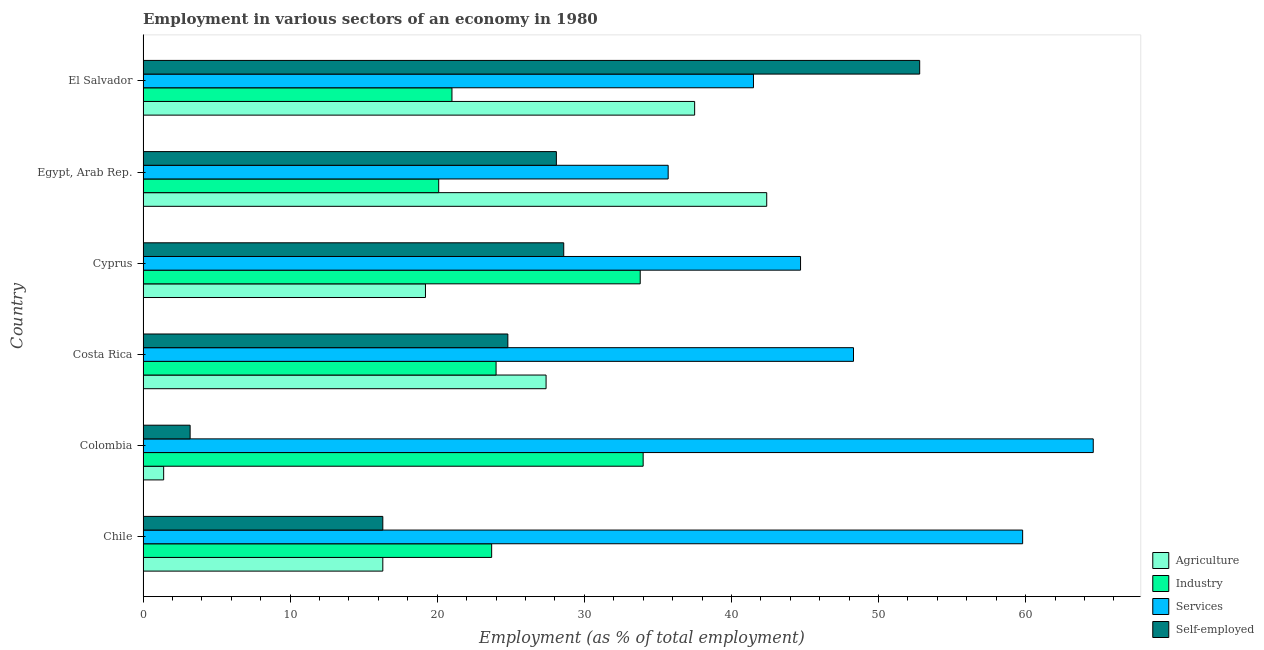How many different coloured bars are there?
Make the answer very short. 4. Are the number of bars per tick equal to the number of legend labels?
Ensure brevity in your answer.  Yes. Are the number of bars on each tick of the Y-axis equal?
Your answer should be compact. Yes. How many bars are there on the 6th tick from the top?
Make the answer very short. 4. What is the percentage of workers in services in Colombia?
Your answer should be very brief. 64.6. Across all countries, what is the maximum percentage of workers in services?
Keep it short and to the point. 64.6. Across all countries, what is the minimum percentage of workers in industry?
Give a very brief answer. 20.1. In which country was the percentage of workers in agriculture maximum?
Provide a succinct answer. Egypt, Arab Rep. In which country was the percentage of workers in services minimum?
Give a very brief answer. Egypt, Arab Rep. What is the total percentage of workers in services in the graph?
Provide a succinct answer. 294.6. What is the difference between the percentage of workers in agriculture in Chile and that in Cyprus?
Your response must be concise. -2.9. What is the average percentage of self employed workers per country?
Offer a very short reply. 25.63. What is the difference between the percentage of workers in industry and percentage of workers in services in Colombia?
Your answer should be compact. -30.6. In how many countries, is the percentage of workers in agriculture greater than 12 %?
Offer a very short reply. 5. What is the ratio of the percentage of workers in agriculture in Chile to that in Colombia?
Offer a very short reply. 11.64. Is the percentage of workers in industry in Chile less than that in Colombia?
Provide a short and direct response. Yes. What is the difference between the highest and the second highest percentage of self employed workers?
Your response must be concise. 24.2. Is the sum of the percentage of workers in services in Costa Rica and Cyprus greater than the maximum percentage of workers in industry across all countries?
Provide a succinct answer. Yes. What does the 1st bar from the top in Cyprus represents?
Provide a short and direct response. Self-employed. What does the 1st bar from the bottom in Colombia represents?
Keep it short and to the point. Agriculture. Is it the case that in every country, the sum of the percentage of workers in agriculture and percentage of workers in industry is greater than the percentage of workers in services?
Your answer should be compact. No. How many bars are there?
Your response must be concise. 24. How many countries are there in the graph?
Offer a very short reply. 6. Does the graph contain grids?
Your answer should be compact. No. Where does the legend appear in the graph?
Your response must be concise. Bottom right. How are the legend labels stacked?
Your answer should be compact. Vertical. What is the title of the graph?
Give a very brief answer. Employment in various sectors of an economy in 1980. Does "Insurance services" appear as one of the legend labels in the graph?
Provide a short and direct response. No. What is the label or title of the X-axis?
Your answer should be very brief. Employment (as % of total employment). What is the label or title of the Y-axis?
Offer a terse response. Country. What is the Employment (as % of total employment) of Agriculture in Chile?
Your answer should be compact. 16.3. What is the Employment (as % of total employment) in Industry in Chile?
Your answer should be very brief. 23.7. What is the Employment (as % of total employment) in Services in Chile?
Your answer should be very brief. 59.8. What is the Employment (as % of total employment) in Self-employed in Chile?
Provide a short and direct response. 16.3. What is the Employment (as % of total employment) in Agriculture in Colombia?
Keep it short and to the point. 1.4. What is the Employment (as % of total employment) of Services in Colombia?
Keep it short and to the point. 64.6. What is the Employment (as % of total employment) of Self-employed in Colombia?
Offer a very short reply. 3.2. What is the Employment (as % of total employment) in Agriculture in Costa Rica?
Offer a very short reply. 27.4. What is the Employment (as % of total employment) in Industry in Costa Rica?
Provide a succinct answer. 24. What is the Employment (as % of total employment) of Services in Costa Rica?
Ensure brevity in your answer.  48.3. What is the Employment (as % of total employment) of Self-employed in Costa Rica?
Ensure brevity in your answer.  24.8. What is the Employment (as % of total employment) in Agriculture in Cyprus?
Ensure brevity in your answer.  19.2. What is the Employment (as % of total employment) in Industry in Cyprus?
Your answer should be very brief. 33.8. What is the Employment (as % of total employment) in Services in Cyprus?
Give a very brief answer. 44.7. What is the Employment (as % of total employment) of Self-employed in Cyprus?
Your answer should be very brief. 28.6. What is the Employment (as % of total employment) of Agriculture in Egypt, Arab Rep.?
Keep it short and to the point. 42.4. What is the Employment (as % of total employment) in Industry in Egypt, Arab Rep.?
Your answer should be very brief. 20.1. What is the Employment (as % of total employment) in Services in Egypt, Arab Rep.?
Your response must be concise. 35.7. What is the Employment (as % of total employment) of Self-employed in Egypt, Arab Rep.?
Your response must be concise. 28.1. What is the Employment (as % of total employment) in Agriculture in El Salvador?
Ensure brevity in your answer.  37.5. What is the Employment (as % of total employment) in Services in El Salvador?
Keep it short and to the point. 41.5. What is the Employment (as % of total employment) of Self-employed in El Salvador?
Ensure brevity in your answer.  52.8. Across all countries, what is the maximum Employment (as % of total employment) of Agriculture?
Ensure brevity in your answer.  42.4. Across all countries, what is the maximum Employment (as % of total employment) of Services?
Your response must be concise. 64.6. Across all countries, what is the maximum Employment (as % of total employment) of Self-employed?
Offer a very short reply. 52.8. Across all countries, what is the minimum Employment (as % of total employment) of Agriculture?
Make the answer very short. 1.4. Across all countries, what is the minimum Employment (as % of total employment) of Industry?
Provide a short and direct response. 20.1. Across all countries, what is the minimum Employment (as % of total employment) of Services?
Offer a very short reply. 35.7. Across all countries, what is the minimum Employment (as % of total employment) of Self-employed?
Provide a succinct answer. 3.2. What is the total Employment (as % of total employment) of Agriculture in the graph?
Your response must be concise. 144.2. What is the total Employment (as % of total employment) of Industry in the graph?
Provide a succinct answer. 156.6. What is the total Employment (as % of total employment) of Services in the graph?
Give a very brief answer. 294.6. What is the total Employment (as % of total employment) of Self-employed in the graph?
Provide a succinct answer. 153.8. What is the difference between the Employment (as % of total employment) in Agriculture in Chile and that in Colombia?
Your answer should be very brief. 14.9. What is the difference between the Employment (as % of total employment) in Industry in Chile and that in Colombia?
Offer a terse response. -10.3. What is the difference between the Employment (as % of total employment) in Self-employed in Chile and that in Colombia?
Provide a short and direct response. 13.1. What is the difference between the Employment (as % of total employment) in Agriculture in Chile and that in Costa Rica?
Make the answer very short. -11.1. What is the difference between the Employment (as % of total employment) of Services in Chile and that in Costa Rica?
Your answer should be very brief. 11.5. What is the difference between the Employment (as % of total employment) in Agriculture in Chile and that in Cyprus?
Ensure brevity in your answer.  -2.9. What is the difference between the Employment (as % of total employment) in Industry in Chile and that in Cyprus?
Keep it short and to the point. -10.1. What is the difference between the Employment (as % of total employment) of Self-employed in Chile and that in Cyprus?
Keep it short and to the point. -12.3. What is the difference between the Employment (as % of total employment) in Agriculture in Chile and that in Egypt, Arab Rep.?
Offer a very short reply. -26.1. What is the difference between the Employment (as % of total employment) in Services in Chile and that in Egypt, Arab Rep.?
Your answer should be very brief. 24.1. What is the difference between the Employment (as % of total employment) in Self-employed in Chile and that in Egypt, Arab Rep.?
Give a very brief answer. -11.8. What is the difference between the Employment (as % of total employment) in Agriculture in Chile and that in El Salvador?
Your response must be concise. -21.2. What is the difference between the Employment (as % of total employment) of Industry in Chile and that in El Salvador?
Make the answer very short. 2.7. What is the difference between the Employment (as % of total employment) in Self-employed in Chile and that in El Salvador?
Ensure brevity in your answer.  -36.5. What is the difference between the Employment (as % of total employment) in Industry in Colombia and that in Costa Rica?
Make the answer very short. 10. What is the difference between the Employment (as % of total employment) of Self-employed in Colombia and that in Costa Rica?
Offer a very short reply. -21.6. What is the difference between the Employment (as % of total employment) in Agriculture in Colombia and that in Cyprus?
Your answer should be compact. -17.8. What is the difference between the Employment (as % of total employment) in Self-employed in Colombia and that in Cyprus?
Offer a terse response. -25.4. What is the difference between the Employment (as % of total employment) of Agriculture in Colombia and that in Egypt, Arab Rep.?
Make the answer very short. -41. What is the difference between the Employment (as % of total employment) of Services in Colombia and that in Egypt, Arab Rep.?
Ensure brevity in your answer.  28.9. What is the difference between the Employment (as % of total employment) in Self-employed in Colombia and that in Egypt, Arab Rep.?
Keep it short and to the point. -24.9. What is the difference between the Employment (as % of total employment) of Agriculture in Colombia and that in El Salvador?
Your answer should be compact. -36.1. What is the difference between the Employment (as % of total employment) in Services in Colombia and that in El Salvador?
Your answer should be very brief. 23.1. What is the difference between the Employment (as % of total employment) in Self-employed in Colombia and that in El Salvador?
Your answer should be very brief. -49.6. What is the difference between the Employment (as % of total employment) of Agriculture in Costa Rica and that in Cyprus?
Your answer should be very brief. 8.2. What is the difference between the Employment (as % of total employment) in Services in Costa Rica and that in Cyprus?
Offer a terse response. 3.6. What is the difference between the Employment (as % of total employment) in Self-employed in Costa Rica and that in Cyprus?
Your answer should be compact. -3.8. What is the difference between the Employment (as % of total employment) of Agriculture in Costa Rica and that in Egypt, Arab Rep.?
Make the answer very short. -15. What is the difference between the Employment (as % of total employment) in Industry in Costa Rica and that in Egypt, Arab Rep.?
Provide a succinct answer. 3.9. What is the difference between the Employment (as % of total employment) in Industry in Costa Rica and that in El Salvador?
Provide a succinct answer. 3. What is the difference between the Employment (as % of total employment) of Self-employed in Costa Rica and that in El Salvador?
Make the answer very short. -28. What is the difference between the Employment (as % of total employment) in Agriculture in Cyprus and that in Egypt, Arab Rep.?
Offer a very short reply. -23.2. What is the difference between the Employment (as % of total employment) in Services in Cyprus and that in Egypt, Arab Rep.?
Offer a terse response. 9. What is the difference between the Employment (as % of total employment) in Self-employed in Cyprus and that in Egypt, Arab Rep.?
Provide a short and direct response. 0.5. What is the difference between the Employment (as % of total employment) in Agriculture in Cyprus and that in El Salvador?
Keep it short and to the point. -18.3. What is the difference between the Employment (as % of total employment) of Industry in Cyprus and that in El Salvador?
Your response must be concise. 12.8. What is the difference between the Employment (as % of total employment) of Services in Cyprus and that in El Salvador?
Ensure brevity in your answer.  3.2. What is the difference between the Employment (as % of total employment) in Self-employed in Cyprus and that in El Salvador?
Offer a terse response. -24.2. What is the difference between the Employment (as % of total employment) in Agriculture in Egypt, Arab Rep. and that in El Salvador?
Your response must be concise. 4.9. What is the difference between the Employment (as % of total employment) of Services in Egypt, Arab Rep. and that in El Salvador?
Your answer should be compact. -5.8. What is the difference between the Employment (as % of total employment) of Self-employed in Egypt, Arab Rep. and that in El Salvador?
Your answer should be very brief. -24.7. What is the difference between the Employment (as % of total employment) in Agriculture in Chile and the Employment (as % of total employment) in Industry in Colombia?
Your answer should be compact. -17.7. What is the difference between the Employment (as % of total employment) of Agriculture in Chile and the Employment (as % of total employment) of Services in Colombia?
Ensure brevity in your answer.  -48.3. What is the difference between the Employment (as % of total employment) in Agriculture in Chile and the Employment (as % of total employment) in Self-employed in Colombia?
Keep it short and to the point. 13.1. What is the difference between the Employment (as % of total employment) of Industry in Chile and the Employment (as % of total employment) of Services in Colombia?
Your response must be concise. -40.9. What is the difference between the Employment (as % of total employment) in Services in Chile and the Employment (as % of total employment) in Self-employed in Colombia?
Your response must be concise. 56.6. What is the difference between the Employment (as % of total employment) of Agriculture in Chile and the Employment (as % of total employment) of Industry in Costa Rica?
Provide a short and direct response. -7.7. What is the difference between the Employment (as % of total employment) of Agriculture in Chile and the Employment (as % of total employment) of Services in Costa Rica?
Provide a succinct answer. -32. What is the difference between the Employment (as % of total employment) in Agriculture in Chile and the Employment (as % of total employment) in Self-employed in Costa Rica?
Offer a terse response. -8.5. What is the difference between the Employment (as % of total employment) of Industry in Chile and the Employment (as % of total employment) of Services in Costa Rica?
Provide a succinct answer. -24.6. What is the difference between the Employment (as % of total employment) in Industry in Chile and the Employment (as % of total employment) in Self-employed in Costa Rica?
Your response must be concise. -1.1. What is the difference between the Employment (as % of total employment) in Agriculture in Chile and the Employment (as % of total employment) in Industry in Cyprus?
Your answer should be compact. -17.5. What is the difference between the Employment (as % of total employment) of Agriculture in Chile and the Employment (as % of total employment) of Services in Cyprus?
Provide a succinct answer. -28.4. What is the difference between the Employment (as % of total employment) of Industry in Chile and the Employment (as % of total employment) of Self-employed in Cyprus?
Give a very brief answer. -4.9. What is the difference between the Employment (as % of total employment) of Services in Chile and the Employment (as % of total employment) of Self-employed in Cyprus?
Offer a very short reply. 31.2. What is the difference between the Employment (as % of total employment) of Agriculture in Chile and the Employment (as % of total employment) of Industry in Egypt, Arab Rep.?
Give a very brief answer. -3.8. What is the difference between the Employment (as % of total employment) of Agriculture in Chile and the Employment (as % of total employment) of Services in Egypt, Arab Rep.?
Your response must be concise. -19.4. What is the difference between the Employment (as % of total employment) of Services in Chile and the Employment (as % of total employment) of Self-employed in Egypt, Arab Rep.?
Provide a short and direct response. 31.7. What is the difference between the Employment (as % of total employment) in Agriculture in Chile and the Employment (as % of total employment) in Industry in El Salvador?
Provide a short and direct response. -4.7. What is the difference between the Employment (as % of total employment) of Agriculture in Chile and the Employment (as % of total employment) of Services in El Salvador?
Keep it short and to the point. -25.2. What is the difference between the Employment (as % of total employment) in Agriculture in Chile and the Employment (as % of total employment) in Self-employed in El Salvador?
Your answer should be very brief. -36.5. What is the difference between the Employment (as % of total employment) in Industry in Chile and the Employment (as % of total employment) in Services in El Salvador?
Provide a succinct answer. -17.8. What is the difference between the Employment (as % of total employment) in Industry in Chile and the Employment (as % of total employment) in Self-employed in El Salvador?
Give a very brief answer. -29.1. What is the difference between the Employment (as % of total employment) of Services in Chile and the Employment (as % of total employment) of Self-employed in El Salvador?
Offer a very short reply. 7. What is the difference between the Employment (as % of total employment) in Agriculture in Colombia and the Employment (as % of total employment) in Industry in Costa Rica?
Ensure brevity in your answer.  -22.6. What is the difference between the Employment (as % of total employment) in Agriculture in Colombia and the Employment (as % of total employment) in Services in Costa Rica?
Ensure brevity in your answer.  -46.9. What is the difference between the Employment (as % of total employment) of Agriculture in Colombia and the Employment (as % of total employment) of Self-employed in Costa Rica?
Keep it short and to the point. -23.4. What is the difference between the Employment (as % of total employment) in Industry in Colombia and the Employment (as % of total employment) in Services in Costa Rica?
Ensure brevity in your answer.  -14.3. What is the difference between the Employment (as % of total employment) of Services in Colombia and the Employment (as % of total employment) of Self-employed in Costa Rica?
Your answer should be very brief. 39.8. What is the difference between the Employment (as % of total employment) in Agriculture in Colombia and the Employment (as % of total employment) in Industry in Cyprus?
Provide a short and direct response. -32.4. What is the difference between the Employment (as % of total employment) of Agriculture in Colombia and the Employment (as % of total employment) of Services in Cyprus?
Keep it short and to the point. -43.3. What is the difference between the Employment (as % of total employment) of Agriculture in Colombia and the Employment (as % of total employment) of Self-employed in Cyprus?
Provide a short and direct response. -27.2. What is the difference between the Employment (as % of total employment) in Industry in Colombia and the Employment (as % of total employment) in Self-employed in Cyprus?
Provide a short and direct response. 5.4. What is the difference between the Employment (as % of total employment) of Agriculture in Colombia and the Employment (as % of total employment) of Industry in Egypt, Arab Rep.?
Keep it short and to the point. -18.7. What is the difference between the Employment (as % of total employment) in Agriculture in Colombia and the Employment (as % of total employment) in Services in Egypt, Arab Rep.?
Offer a very short reply. -34.3. What is the difference between the Employment (as % of total employment) in Agriculture in Colombia and the Employment (as % of total employment) in Self-employed in Egypt, Arab Rep.?
Your answer should be very brief. -26.7. What is the difference between the Employment (as % of total employment) of Industry in Colombia and the Employment (as % of total employment) of Services in Egypt, Arab Rep.?
Ensure brevity in your answer.  -1.7. What is the difference between the Employment (as % of total employment) of Industry in Colombia and the Employment (as % of total employment) of Self-employed in Egypt, Arab Rep.?
Offer a very short reply. 5.9. What is the difference between the Employment (as % of total employment) in Services in Colombia and the Employment (as % of total employment) in Self-employed in Egypt, Arab Rep.?
Provide a succinct answer. 36.5. What is the difference between the Employment (as % of total employment) in Agriculture in Colombia and the Employment (as % of total employment) in Industry in El Salvador?
Provide a short and direct response. -19.6. What is the difference between the Employment (as % of total employment) in Agriculture in Colombia and the Employment (as % of total employment) in Services in El Salvador?
Your answer should be very brief. -40.1. What is the difference between the Employment (as % of total employment) of Agriculture in Colombia and the Employment (as % of total employment) of Self-employed in El Salvador?
Give a very brief answer. -51.4. What is the difference between the Employment (as % of total employment) in Industry in Colombia and the Employment (as % of total employment) in Self-employed in El Salvador?
Make the answer very short. -18.8. What is the difference between the Employment (as % of total employment) of Services in Colombia and the Employment (as % of total employment) of Self-employed in El Salvador?
Your answer should be very brief. 11.8. What is the difference between the Employment (as % of total employment) in Agriculture in Costa Rica and the Employment (as % of total employment) in Industry in Cyprus?
Give a very brief answer. -6.4. What is the difference between the Employment (as % of total employment) of Agriculture in Costa Rica and the Employment (as % of total employment) of Services in Cyprus?
Ensure brevity in your answer.  -17.3. What is the difference between the Employment (as % of total employment) in Agriculture in Costa Rica and the Employment (as % of total employment) in Self-employed in Cyprus?
Provide a succinct answer. -1.2. What is the difference between the Employment (as % of total employment) in Industry in Costa Rica and the Employment (as % of total employment) in Services in Cyprus?
Keep it short and to the point. -20.7. What is the difference between the Employment (as % of total employment) in Industry in Costa Rica and the Employment (as % of total employment) in Self-employed in Cyprus?
Your answer should be compact. -4.6. What is the difference between the Employment (as % of total employment) of Agriculture in Costa Rica and the Employment (as % of total employment) of Industry in Egypt, Arab Rep.?
Keep it short and to the point. 7.3. What is the difference between the Employment (as % of total employment) in Industry in Costa Rica and the Employment (as % of total employment) in Self-employed in Egypt, Arab Rep.?
Provide a succinct answer. -4.1. What is the difference between the Employment (as % of total employment) of Services in Costa Rica and the Employment (as % of total employment) of Self-employed in Egypt, Arab Rep.?
Provide a succinct answer. 20.2. What is the difference between the Employment (as % of total employment) in Agriculture in Costa Rica and the Employment (as % of total employment) in Industry in El Salvador?
Your response must be concise. 6.4. What is the difference between the Employment (as % of total employment) in Agriculture in Costa Rica and the Employment (as % of total employment) in Services in El Salvador?
Your response must be concise. -14.1. What is the difference between the Employment (as % of total employment) of Agriculture in Costa Rica and the Employment (as % of total employment) of Self-employed in El Salvador?
Provide a succinct answer. -25.4. What is the difference between the Employment (as % of total employment) of Industry in Costa Rica and the Employment (as % of total employment) of Services in El Salvador?
Your answer should be compact. -17.5. What is the difference between the Employment (as % of total employment) of Industry in Costa Rica and the Employment (as % of total employment) of Self-employed in El Salvador?
Ensure brevity in your answer.  -28.8. What is the difference between the Employment (as % of total employment) in Agriculture in Cyprus and the Employment (as % of total employment) in Industry in Egypt, Arab Rep.?
Ensure brevity in your answer.  -0.9. What is the difference between the Employment (as % of total employment) of Agriculture in Cyprus and the Employment (as % of total employment) of Services in Egypt, Arab Rep.?
Your answer should be compact. -16.5. What is the difference between the Employment (as % of total employment) in Agriculture in Cyprus and the Employment (as % of total employment) in Self-employed in Egypt, Arab Rep.?
Provide a succinct answer. -8.9. What is the difference between the Employment (as % of total employment) of Industry in Cyprus and the Employment (as % of total employment) of Self-employed in Egypt, Arab Rep.?
Ensure brevity in your answer.  5.7. What is the difference between the Employment (as % of total employment) in Services in Cyprus and the Employment (as % of total employment) in Self-employed in Egypt, Arab Rep.?
Provide a short and direct response. 16.6. What is the difference between the Employment (as % of total employment) of Agriculture in Cyprus and the Employment (as % of total employment) of Industry in El Salvador?
Offer a terse response. -1.8. What is the difference between the Employment (as % of total employment) of Agriculture in Cyprus and the Employment (as % of total employment) of Services in El Salvador?
Your answer should be very brief. -22.3. What is the difference between the Employment (as % of total employment) of Agriculture in Cyprus and the Employment (as % of total employment) of Self-employed in El Salvador?
Provide a short and direct response. -33.6. What is the difference between the Employment (as % of total employment) in Agriculture in Egypt, Arab Rep. and the Employment (as % of total employment) in Industry in El Salvador?
Offer a terse response. 21.4. What is the difference between the Employment (as % of total employment) in Industry in Egypt, Arab Rep. and the Employment (as % of total employment) in Services in El Salvador?
Offer a terse response. -21.4. What is the difference between the Employment (as % of total employment) of Industry in Egypt, Arab Rep. and the Employment (as % of total employment) of Self-employed in El Salvador?
Make the answer very short. -32.7. What is the difference between the Employment (as % of total employment) of Services in Egypt, Arab Rep. and the Employment (as % of total employment) of Self-employed in El Salvador?
Your answer should be very brief. -17.1. What is the average Employment (as % of total employment) of Agriculture per country?
Make the answer very short. 24.03. What is the average Employment (as % of total employment) of Industry per country?
Your response must be concise. 26.1. What is the average Employment (as % of total employment) in Services per country?
Offer a terse response. 49.1. What is the average Employment (as % of total employment) in Self-employed per country?
Your answer should be very brief. 25.63. What is the difference between the Employment (as % of total employment) of Agriculture and Employment (as % of total employment) of Services in Chile?
Your response must be concise. -43.5. What is the difference between the Employment (as % of total employment) of Industry and Employment (as % of total employment) of Services in Chile?
Keep it short and to the point. -36.1. What is the difference between the Employment (as % of total employment) of Industry and Employment (as % of total employment) of Self-employed in Chile?
Ensure brevity in your answer.  7.4. What is the difference between the Employment (as % of total employment) of Services and Employment (as % of total employment) of Self-employed in Chile?
Provide a short and direct response. 43.5. What is the difference between the Employment (as % of total employment) of Agriculture and Employment (as % of total employment) of Industry in Colombia?
Offer a very short reply. -32.6. What is the difference between the Employment (as % of total employment) in Agriculture and Employment (as % of total employment) in Services in Colombia?
Provide a succinct answer. -63.2. What is the difference between the Employment (as % of total employment) in Agriculture and Employment (as % of total employment) in Self-employed in Colombia?
Offer a terse response. -1.8. What is the difference between the Employment (as % of total employment) of Industry and Employment (as % of total employment) of Services in Colombia?
Your response must be concise. -30.6. What is the difference between the Employment (as % of total employment) in Industry and Employment (as % of total employment) in Self-employed in Colombia?
Provide a short and direct response. 30.8. What is the difference between the Employment (as % of total employment) in Services and Employment (as % of total employment) in Self-employed in Colombia?
Offer a terse response. 61.4. What is the difference between the Employment (as % of total employment) of Agriculture and Employment (as % of total employment) of Services in Costa Rica?
Offer a very short reply. -20.9. What is the difference between the Employment (as % of total employment) in Agriculture and Employment (as % of total employment) in Self-employed in Costa Rica?
Offer a terse response. 2.6. What is the difference between the Employment (as % of total employment) of Industry and Employment (as % of total employment) of Services in Costa Rica?
Provide a succinct answer. -24.3. What is the difference between the Employment (as % of total employment) in Services and Employment (as % of total employment) in Self-employed in Costa Rica?
Provide a succinct answer. 23.5. What is the difference between the Employment (as % of total employment) in Agriculture and Employment (as % of total employment) in Industry in Cyprus?
Offer a terse response. -14.6. What is the difference between the Employment (as % of total employment) in Agriculture and Employment (as % of total employment) in Services in Cyprus?
Your answer should be very brief. -25.5. What is the difference between the Employment (as % of total employment) of Agriculture and Employment (as % of total employment) of Self-employed in Cyprus?
Your answer should be very brief. -9.4. What is the difference between the Employment (as % of total employment) of Industry and Employment (as % of total employment) of Self-employed in Cyprus?
Ensure brevity in your answer.  5.2. What is the difference between the Employment (as % of total employment) in Services and Employment (as % of total employment) in Self-employed in Cyprus?
Give a very brief answer. 16.1. What is the difference between the Employment (as % of total employment) of Agriculture and Employment (as % of total employment) of Industry in Egypt, Arab Rep.?
Your answer should be very brief. 22.3. What is the difference between the Employment (as % of total employment) in Industry and Employment (as % of total employment) in Services in Egypt, Arab Rep.?
Provide a succinct answer. -15.6. What is the difference between the Employment (as % of total employment) of Agriculture and Employment (as % of total employment) of Self-employed in El Salvador?
Keep it short and to the point. -15.3. What is the difference between the Employment (as % of total employment) of Industry and Employment (as % of total employment) of Services in El Salvador?
Give a very brief answer. -20.5. What is the difference between the Employment (as % of total employment) of Industry and Employment (as % of total employment) of Self-employed in El Salvador?
Your response must be concise. -31.8. What is the difference between the Employment (as % of total employment) of Services and Employment (as % of total employment) of Self-employed in El Salvador?
Your answer should be very brief. -11.3. What is the ratio of the Employment (as % of total employment) in Agriculture in Chile to that in Colombia?
Ensure brevity in your answer.  11.64. What is the ratio of the Employment (as % of total employment) of Industry in Chile to that in Colombia?
Provide a succinct answer. 0.7. What is the ratio of the Employment (as % of total employment) in Services in Chile to that in Colombia?
Make the answer very short. 0.93. What is the ratio of the Employment (as % of total employment) in Self-employed in Chile to that in Colombia?
Offer a terse response. 5.09. What is the ratio of the Employment (as % of total employment) of Agriculture in Chile to that in Costa Rica?
Give a very brief answer. 0.59. What is the ratio of the Employment (as % of total employment) of Industry in Chile to that in Costa Rica?
Ensure brevity in your answer.  0.99. What is the ratio of the Employment (as % of total employment) in Services in Chile to that in Costa Rica?
Offer a terse response. 1.24. What is the ratio of the Employment (as % of total employment) in Self-employed in Chile to that in Costa Rica?
Provide a short and direct response. 0.66. What is the ratio of the Employment (as % of total employment) of Agriculture in Chile to that in Cyprus?
Ensure brevity in your answer.  0.85. What is the ratio of the Employment (as % of total employment) of Industry in Chile to that in Cyprus?
Your answer should be compact. 0.7. What is the ratio of the Employment (as % of total employment) of Services in Chile to that in Cyprus?
Make the answer very short. 1.34. What is the ratio of the Employment (as % of total employment) in Self-employed in Chile to that in Cyprus?
Make the answer very short. 0.57. What is the ratio of the Employment (as % of total employment) in Agriculture in Chile to that in Egypt, Arab Rep.?
Offer a terse response. 0.38. What is the ratio of the Employment (as % of total employment) of Industry in Chile to that in Egypt, Arab Rep.?
Your answer should be very brief. 1.18. What is the ratio of the Employment (as % of total employment) in Services in Chile to that in Egypt, Arab Rep.?
Give a very brief answer. 1.68. What is the ratio of the Employment (as % of total employment) of Self-employed in Chile to that in Egypt, Arab Rep.?
Your response must be concise. 0.58. What is the ratio of the Employment (as % of total employment) in Agriculture in Chile to that in El Salvador?
Keep it short and to the point. 0.43. What is the ratio of the Employment (as % of total employment) in Industry in Chile to that in El Salvador?
Ensure brevity in your answer.  1.13. What is the ratio of the Employment (as % of total employment) in Services in Chile to that in El Salvador?
Offer a terse response. 1.44. What is the ratio of the Employment (as % of total employment) of Self-employed in Chile to that in El Salvador?
Your response must be concise. 0.31. What is the ratio of the Employment (as % of total employment) of Agriculture in Colombia to that in Costa Rica?
Ensure brevity in your answer.  0.05. What is the ratio of the Employment (as % of total employment) in Industry in Colombia to that in Costa Rica?
Ensure brevity in your answer.  1.42. What is the ratio of the Employment (as % of total employment) of Services in Colombia to that in Costa Rica?
Keep it short and to the point. 1.34. What is the ratio of the Employment (as % of total employment) of Self-employed in Colombia to that in Costa Rica?
Provide a short and direct response. 0.13. What is the ratio of the Employment (as % of total employment) in Agriculture in Colombia to that in Cyprus?
Offer a terse response. 0.07. What is the ratio of the Employment (as % of total employment) in Industry in Colombia to that in Cyprus?
Provide a succinct answer. 1.01. What is the ratio of the Employment (as % of total employment) of Services in Colombia to that in Cyprus?
Keep it short and to the point. 1.45. What is the ratio of the Employment (as % of total employment) in Self-employed in Colombia to that in Cyprus?
Provide a short and direct response. 0.11. What is the ratio of the Employment (as % of total employment) in Agriculture in Colombia to that in Egypt, Arab Rep.?
Give a very brief answer. 0.03. What is the ratio of the Employment (as % of total employment) in Industry in Colombia to that in Egypt, Arab Rep.?
Give a very brief answer. 1.69. What is the ratio of the Employment (as % of total employment) in Services in Colombia to that in Egypt, Arab Rep.?
Your response must be concise. 1.81. What is the ratio of the Employment (as % of total employment) of Self-employed in Colombia to that in Egypt, Arab Rep.?
Your answer should be very brief. 0.11. What is the ratio of the Employment (as % of total employment) of Agriculture in Colombia to that in El Salvador?
Your response must be concise. 0.04. What is the ratio of the Employment (as % of total employment) of Industry in Colombia to that in El Salvador?
Offer a terse response. 1.62. What is the ratio of the Employment (as % of total employment) of Services in Colombia to that in El Salvador?
Your answer should be very brief. 1.56. What is the ratio of the Employment (as % of total employment) in Self-employed in Colombia to that in El Salvador?
Give a very brief answer. 0.06. What is the ratio of the Employment (as % of total employment) in Agriculture in Costa Rica to that in Cyprus?
Your response must be concise. 1.43. What is the ratio of the Employment (as % of total employment) of Industry in Costa Rica to that in Cyprus?
Offer a very short reply. 0.71. What is the ratio of the Employment (as % of total employment) in Services in Costa Rica to that in Cyprus?
Your response must be concise. 1.08. What is the ratio of the Employment (as % of total employment) of Self-employed in Costa Rica to that in Cyprus?
Provide a short and direct response. 0.87. What is the ratio of the Employment (as % of total employment) of Agriculture in Costa Rica to that in Egypt, Arab Rep.?
Your response must be concise. 0.65. What is the ratio of the Employment (as % of total employment) of Industry in Costa Rica to that in Egypt, Arab Rep.?
Your answer should be very brief. 1.19. What is the ratio of the Employment (as % of total employment) of Services in Costa Rica to that in Egypt, Arab Rep.?
Offer a very short reply. 1.35. What is the ratio of the Employment (as % of total employment) in Self-employed in Costa Rica to that in Egypt, Arab Rep.?
Provide a succinct answer. 0.88. What is the ratio of the Employment (as % of total employment) of Agriculture in Costa Rica to that in El Salvador?
Provide a short and direct response. 0.73. What is the ratio of the Employment (as % of total employment) of Services in Costa Rica to that in El Salvador?
Offer a terse response. 1.16. What is the ratio of the Employment (as % of total employment) in Self-employed in Costa Rica to that in El Salvador?
Offer a terse response. 0.47. What is the ratio of the Employment (as % of total employment) of Agriculture in Cyprus to that in Egypt, Arab Rep.?
Provide a succinct answer. 0.45. What is the ratio of the Employment (as % of total employment) of Industry in Cyprus to that in Egypt, Arab Rep.?
Offer a terse response. 1.68. What is the ratio of the Employment (as % of total employment) in Services in Cyprus to that in Egypt, Arab Rep.?
Provide a short and direct response. 1.25. What is the ratio of the Employment (as % of total employment) of Self-employed in Cyprus to that in Egypt, Arab Rep.?
Make the answer very short. 1.02. What is the ratio of the Employment (as % of total employment) of Agriculture in Cyprus to that in El Salvador?
Your answer should be compact. 0.51. What is the ratio of the Employment (as % of total employment) in Industry in Cyprus to that in El Salvador?
Provide a succinct answer. 1.61. What is the ratio of the Employment (as % of total employment) of Services in Cyprus to that in El Salvador?
Your answer should be compact. 1.08. What is the ratio of the Employment (as % of total employment) in Self-employed in Cyprus to that in El Salvador?
Provide a succinct answer. 0.54. What is the ratio of the Employment (as % of total employment) of Agriculture in Egypt, Arab Rep. to that in El Salvador?
Keep it short and to the point. 1.13. What is the ratio of the Employment (as % of total employment) of Industry in Egypt, Arab Rep. to that in El Salvador?
Provide a short and direct response. 0.96. What is the ratio of the Employment (as % of total employment) in Services in Egypt, Arab Rep. to that in El Salvador?
Provide a short and direct response. 0.86. What is the ratio of the Employment (as % of total employment) in Self-employed in Egypt, Arab Rep. to that in El Salvador?
Your response must be concise. 0.53. What is the difference between the highest and the second highest Employment (as % of total employment) in Services?
Your answer should be compact. 4.8. What is the difference between the highest and the second highest Employment (as % of total employment) of Self-employed?
Give a very brief answer. 24.2. What is the difference between the highest and the lowest Employment (as % of total employment) of Services?
Make the answer very short. 28.9. What is the difference between the highest and the lowest Employment (as % of total employment) of Self-employed?
Your answer should be very brief. 49.6. 